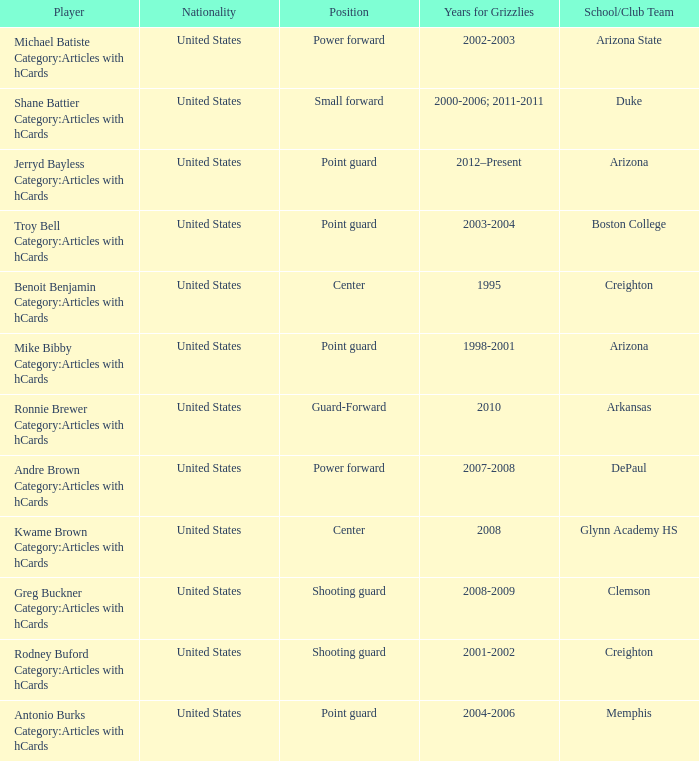Which Player has position of power forward and School/Club Team of Depaul? Andre Brown Category:Articles with hCards. 